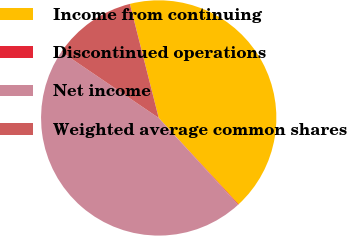Convert chart to OTSL. <chart><loc_0><loc_0><loc_500><loc_500><pie_chart><fcel>Income from continuing<fcel>Discontinued operations<fcel>Net income<fcel>Weighted average common shares<nl><fcel>42.07%<fcel>0.09%<fcel>46.28%<fcel>11.56%<nl></chart> 